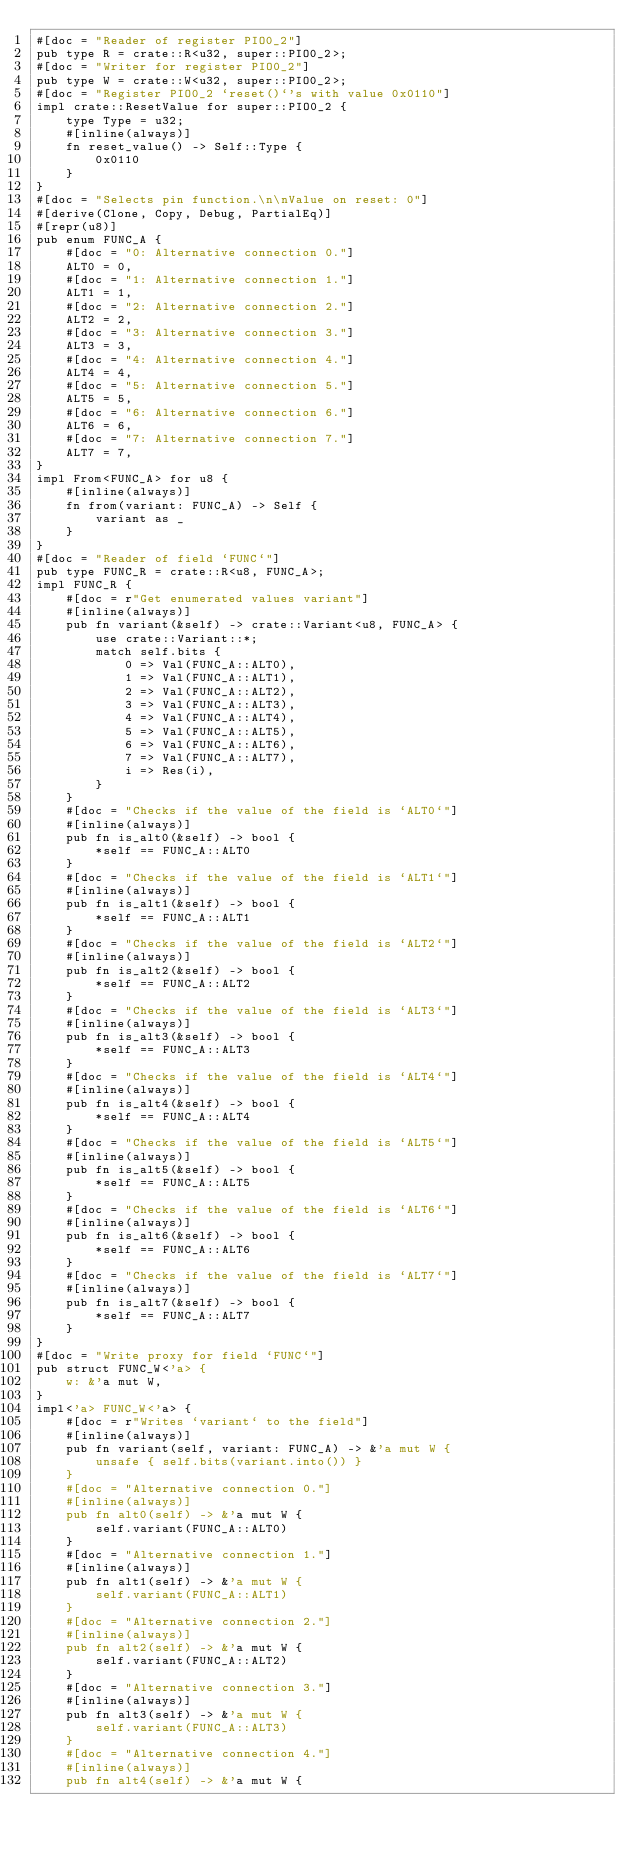<code> <loc_0><loc_0><loc_500><loc_500><_Rust_>#[doc = "Reader of register PIO0_2"]
pub type R = crate::R<u32, super::PIO0_2>;
#[doc = "Writer for register PIO0_2"]
pub type W = crate::W<u32, super::PIO0_2>;
#[doc = "Register PIO0_2 `reset()`'s with value 0x0110"]
impl crate::ResetValue for super::PIO0_2 {
    type Type = u32;
    #[inline(always)]
    fn reset_value() -> Self::Type {
        0x0110
    }
}
#[doc = "Selects pin function.\n\nValue on reset: 0"]
#[derive(Clone, Copy, Debug, PartialEq)]
#[repr(u8)]
pub enum FUNC_A {
    #[doc = "0: Alternative connection 0."]
    ALT0 = 0,
    #[doc = "1: Alternative connection 1."]
    ALT1 = 1,
    #[doc = "2: Alternative connection 2."]
    ALT2 = 2,
    #[doc = "3: Alternative connection 3."]
    ALT3 = 3,
    #[doc = "4: Alternative connection 4."]
    ALT4 = 4,
    #[doc = "5: Alternative connection 5."]
    ALT5 = 5,
    #[doc = "6: Alternative connection 6."]
    ALT6 = 6,
    #[doc = "7: Alternative connection 7."]
    ALT7 = 7,
}
impl From<FUNC_A> for u8 {
    #[inline(always)]
    fn from(variant: FUNC_A) -> Self {
        variant as _
    }
}
#[doc = "Reader of field `FUNC`"]
pub type FUNC_R = crate::R<u8, FUNC_A>;
impl FUNC_R {
    #[doc = r"Get enumerated values variant"]
    #[inline(always)]
    pub fn variant(&self) -> crate::Variant<u8, FUNC_A> {
        use crate::Variant::*;
        match self.bits {
            0 => Val(FUNC_A::ALT0),
            1 => Val(FUNC_A::ALT1),
            2 => Val(FUNC_A::ALT2),
            3 => Val(FUNC_A::ALT3),
            4 => Val(FUNC_A::ALT4),
            5 => Val(FUNC_A::ALT5),
            6 => Val(FUNC_A::ALT6),
            7 => Val(FUNC_A::ALT7),
            i => Res(i),
        }
    }
    #[doc = "Checks if the value of the field is `ALT0`"]
    #[inline(always)]
    pub fn is_alt0(&self) -> bool {
        *self == FUNC_A::ALT0
    }
    #[doc = "Checks if the value of the field is `ALT1`"]
    #[inline(always)]
    pub fn is_alt1(&self) -> bool {
        *self == FUNC_A::ALT1
    }
    #[doc = "Checks if the value of the field is `ALT2`"]
    #[inline(always)]
    pub fn is_alt2(&self) -> bool {
        *self == FUNC_A::ALT2
    }
    #[doc = "Checks if the value of the field is `ALT3`"]
    #[inline(always)]
    pub fn is_alt3(&self) -> bool {
        *self == FUNC_A::ALT3
    }
    #[doc = "Checks if the value of the field is `ALT4`"]
    #[inline(always)]
    pub fn is_alt4(&self) -> bool {
        *self == FUNC_A::ALT4
    }
    #[doc = "Checks if the value of the field is `ALT5`"]
    #[inline(always)]
    pub fn is_alt5(&self) -> bool {
        *self == FUNC_A::ALT5
    }
    #[doc = "Checks if the value of the field is `ALT6`"]
    #[inline(always)]
    pub fn is_alt6(&self) -> bool {
        *self == FUNC_A::ALT6
    }
    #[doc = "Checks if the value of the field is `ALT7`"]
    #[inline(always)]
    pub fn is_alt7(&self) -> bool {
        *self == FUNC_A::ALT7
    }
}
#[doc = "Write proxy for field `FUNC`"]
pub struct FUNC_W<'a> {
    w: &'a mut W,
}
impl<'a> FUNC_W<'a> {
    #[doc = r"Writes `variant` to the field"]
    #[inline(always)]
    pub fn variant(self, variant: FUNC_A) -> &'a mut W {
        unsafe { self.bits(variant.into()) }
    }
    #[doc = "Alternative connection 0."]
    #[inline(always)]
    pub fn alt0(self) -> &'a mut W {
        self.variant(FUNC_A::ALT0)
    }
    #[doc = "Alternative connection 1."]
    #[inline(always)]
    pub fn alt1(self) -> &'a mut W {
        self.variant(FUNC_A::ALT1)
    }
    #[doc = "Alternative connection 2."]
    #[inline(always)]
    pub fn alt2(self) -> &'a mut W {
        self.variant(FUNC_A::ALT2)
    }
    #[doc = "Alternative connection 3."]
    #[inline(always)]
    pub fn alt3(self) -> &'a mut W {
        self.variant(FUNC_A::ALT3)
    }
    #[doc = "Alternative connection 4."]
    #[inline(always)]
    pub fn alt4(self) -> &'a mut W {</code> 